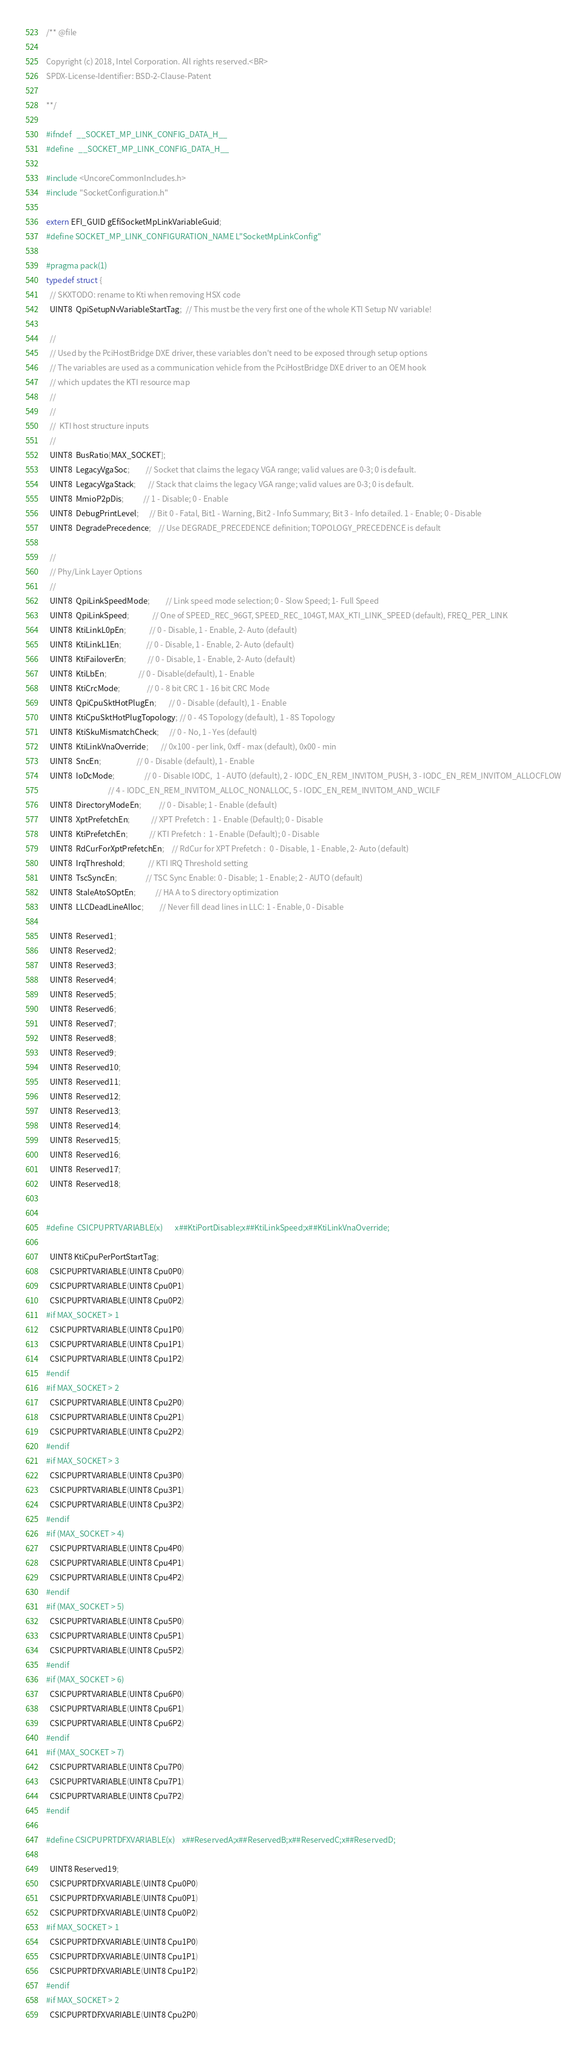<code> <loc_0><loc_0><loc_500><loc_500><_C_>/** @file

Copyright (c) 2018, Intel Corporation. All rights reserved.<BR>
SPDX-License-Identifier: BSD-2-Clause-Patent

**/

#ifndef   __SOCKET_MP_LINK_CONFIG_DATA_H__
#define   __SOCKET_MP_LINK_CONFIG_DATA_H__

#include <UncoreCommonIncludes.h>
#include "SocketConfiguration.h"

extern EFI_GUID gEfiSocketMpLinkVariableGuid;
#define SOCKET_MP_LINK_CONFIGURATION_NAME L"SocketMpLinkConfig"

#pragma pack(1)
typedef struct {
  // SKXTODO: rename to Kti when removing HSX code
  UINT8  QpiSetupNvVariableStartTag;  // This must be the very first one of the whole KTI Setup NV variable!

  //
  // Used by the PciHostBridge DXE driver, these variables don't need to be exposed through setup options
  // The variables are used as a communication vehicle from the PciHostBridge DXE driver to an OEM hook
  // which updates the KTI resource map
  //
  //
  //  KTI host structure inputs
  //
  UINT8  BusRatio[MAX_SOCKET];
  UINT8  LegacyVgaSoc;         // Socket that claims the legacy VGA range; valid values are 0-3; 0 is default.
  UINT8  LegacyVgaStack;       // Stack that claims the legacy VGA range; valid values are 0-3; 0 is default.
  UINT8  MmioP2pDis;           // 1 - Disable; 0 - Enable
  UINT8  DebugPrintLevel;      // Bit 0 - Fatal, Bit1 - Warning, Bit2 - Info Summary; Bit 3 - Info detailed. 1 - Enable; 0 - Disable
  UINT8  DegradePrecedence;    // Use DEGRADE_PRECEDENCE definition; TOPOLOGY_PRECEDENCE is default

  //
  // Phy/Link Layer Options
  //
  UINT8  QpiLinkSpeedMode;         // Link speed mode selection; 0 - Slow Speed; 1- Full Speed
  UINT8  QpiLinkSpeed;             // One of SPEED_REC_96GT, SPEED_REC_104GT, MAX_KTI_LINK_SPEED (default), FREQ_PER_LINK
  UINT8  KtiLinkL0pEn;             // 0 - Disable, 1 - Enable, 2- Auto (default)
  UINT8  KtiLinkL1En;              // 0 - Disable, 1 - Enable, 2- Auto (default)
  UINT8  KtiFailoverEn;            // 0 - Disable, 1 - Enable, 2- Auto (default)
  UINT8  KtiLbEn;                  // 0 - Disable(default), 1 - Enable
  UINT8  KtiCrcMode;               // 0 - 8 bit CRC 1 - 16 bit CRC Mode
  UINT8  QpiCpuSktHotPlugEn;       // 0 - Disable (default), 1 - Enable
  UINT8  KtiCpuSktHotPlugTopology; // 0 - 4S Topology (default), 1 - 8S Topology
  UINT8  KtiSkuMismatchCheck;      // 0 - No, 1 - Yes (default)
  UINT8  KtiLinkVnaOverride;       // 0x100 - per link, 0xff - max (default), 0x00 - min
  UINT8  SncEn;                    // 0 - Disable (default), 1 - Enable
  UINT8  IoDcMode;                 // 0 - Disable IODC,  1 - AUTO (default), 2 - IODC_EN_REM_INVITOM_PUSH, 3 - IODC_EN_REM_INVITOM_ALLOCFLOW
                                   // 4 - IODC_EN_REM_INVITOM_ALLOC_NONALLOC, 5 - IODC_EN_REM_INVITOM_AND_WCILF
  UINT8  DirectoryModeEn;          // 0 - Disable; 1 - Enable (default)
  UINT8  XptPrefetchEn;            // XPT Prefetch :  1 - Enable (Default); 0 - Disable
  UINT8  KtiPrefetchEn;            // KTI Prefetch :  1 - Enable (Default); 0 - Disable
  UINT8  RdCurForXptPrefetchEn;    // RdCur for XPT Prefetch :  0 - Disable, 1 - Enable, 2- Auto (default)
  UINT8  IrqThreshold;             // KTI IRQ Threshold setting
  UINT8  TscSyncEn;                // TSC Sync Enable: 0 - Disable; 1 - Enable; 2 - AUTO (default)
  UINT8  StaleAtoSOptEn;           // HA A to S directory optimization
  UINT8  LLCDeadLineAlloc;         // Never fill dead lines in LLC: 1 - Enable, 0 - Disable

  UINT8  Reserved1;
  UINT8  Reserved2;
  UINT8  Reserved3;
  UINT8  Reserved4;
  UINT8  Reserved5;
  UINT8  Reserved6;
  UINT8  Reserved7;
  UINT8  Reserved8;
  UINT8  Reserved9;
  UINT8  Reserved10;
  UINT8  Reserved11;
  UINT8  Reserved12;
  UINT8  Reserved13;
  UINT8  Reserved14;
  UINT8  Reserved15;
  UINT8  Reserved16;
  UINT8  Reserved17;
  UINT8  Reserved18;


#define  CSICPUPRTVARIABLE(x)       x##KtiPortDisable;x##KtiLinkSpeed;x##KtiLinkVnaOverride;

  UINT8 KtiCpuPerPortStartTag;
  CSICPUPRTVARIABLE(UINT8 Cpu0P0)
  CSICPUPRTVARIABLE(UINT8 Cpu0P1)
  CSICPUPRTVARIABLE(UINT8 Cpu0P2)
#if MAX_SOCKET > 1
  CSICPUPRTVARIABLE(UINT8 Cpu1P0)
  CSICPUPRTVARIABLE(UINT8 Cpu1P1)
  CSICPUPRTVARIABLE(UINT8 Cpu1P2)
#endif
#if MAX_SOCKET > 2
  CSICPUPRTVARIABLE(UINT8 Cpu2P0)
  CSICPUPRTVARIABLE(UINT8 Cpu2P1)
  CSICPUPRTVARIABLE(UINT8 Cpu2P2)
#endif
#if MAX_SOCKET > 3
  CSICPUPRTVARIABLE(UINT8 Cpu3P0)
  CSICPUPRTVARIABLE(UINT8 Cpu3P1)
  CSICPUPRTVARIABLE(UINT8 Cpu3P2)
#endif
#if (MAX_SOCKET > 4)
  CSICPUPRTVARIABLE(UINT8 Cpu4P0)
  CSICPUPRTVARIABLE(UINT8 Cpu4P1)
  CSICPUPRTVARIABLE(UINT8 Cpu4P2)
#endif
#if (MAX_SOCKET > 5)
  CSICPUPRTVARIABLE(UINT8 Cpu5P0)
  CSICPUPRTVARIABLE(UINT8 Cpu5P1)
  CSICPUPRTVARIABLE(UINT8 Cpu5P2)
#endif
#if (MAX_SOCKET > 6)
  CSICPUPRTVARIABLE(UINT8 Cpu6P0)
  CSICPUPRTVARIABLE(UINT8 Cpu6P1)
  CSICPUPRTVARIABLE(UINT8 Cpu6P2)
#endif
#if (MAX_SOCKET > 7)
  CSICPUPRTVARIABLE(UINT8 Cpu7P0)
  CSICPUPRTVARIABLE(UINT8 Cpu7P1)
  CSICPUPRTVARIABLE(UINT8 Cpu7P2)
#endif

#define CSICPUPRTDFXVARIABLE(x)    x##ReservedA;x##ReservedB;x##ReservedC;x##ReservedD;

  UINT8 Reserved19;
  CSICPUPRTDFXVARIABLE(UINT8 Cpu0P0)
  CSICPUPRTDFXVARIABLE(UINT8 Cpu0P1)
  CSICPUPRTDFXVARIABLE(UINT8 Cpu0P2)
#if MAX_SOCKET > 1
  CSICPUPRTDFXVARIABLE(UINT8 Cpu1P0)
  CSICPUPRTDFXVARIABLE(UINT8 Cpu1P1)
  CSICPUPRTDFXVARIABLE(UINT8 Cpu1P2)
#endif
#if MAX_SOCKET > 2
  CSICPUPRTDFXVARIABLE(UINT8 Cpu2P0)</code> 